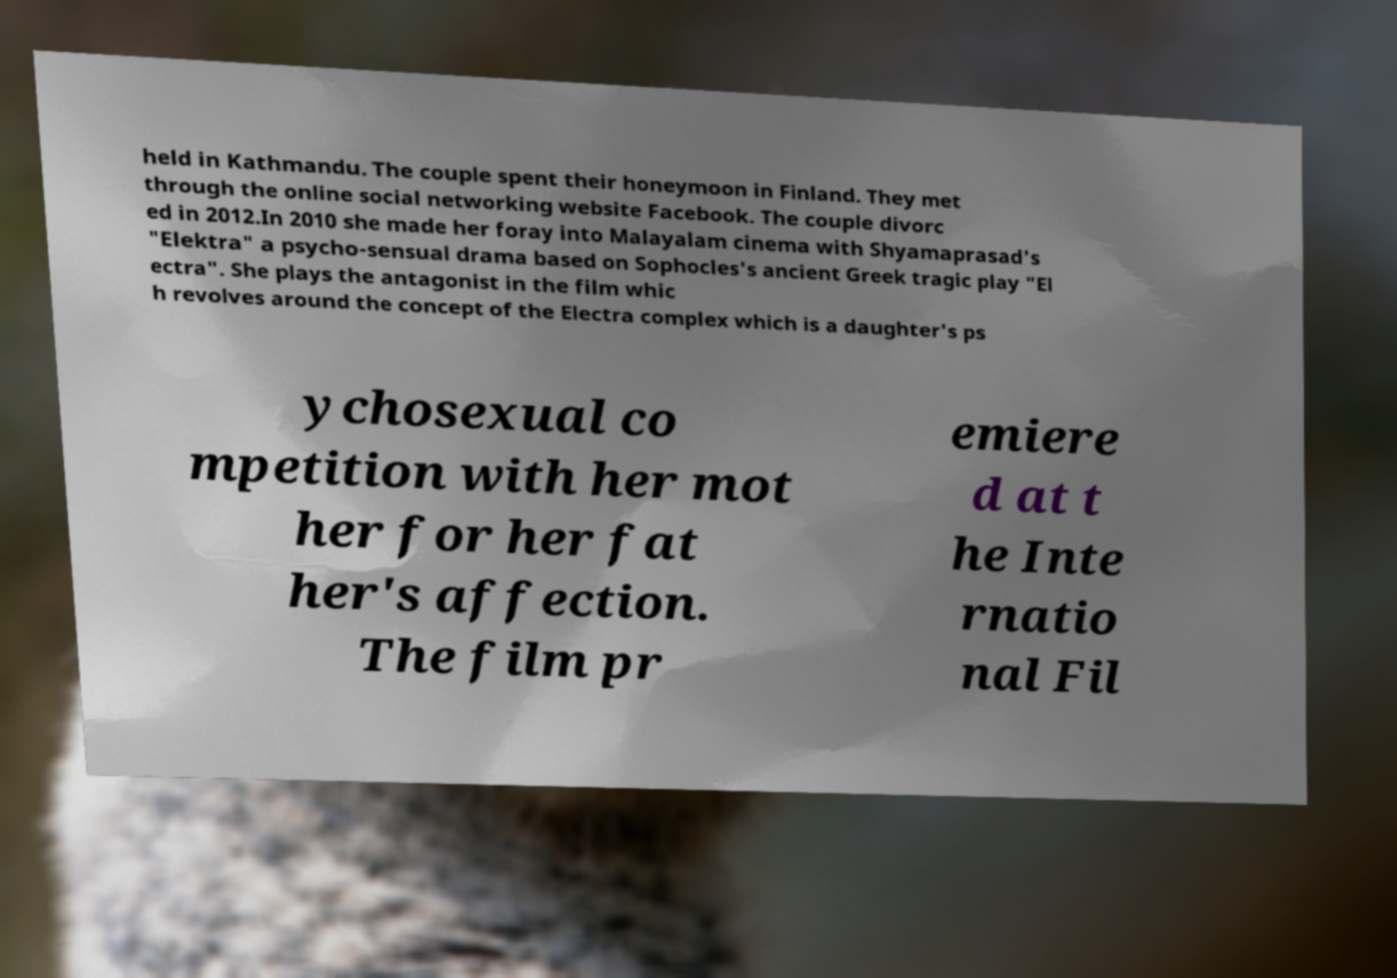Please identify and transcribe the text found in this image. held in Kathmandu. The couple spent their honeymoon in Finland. They met through the online social networking website Facebook. The couple divorc ed in 2012.In 2010 she made her foray into Malayalam cinema with Shyamaprasad's "Elektra" a psycho-sensual drama based on Sophocles's ancient Greek tragic play "El ectra". She plays the antagonist in the film whic h revolves around the concept of the Electra complex which is a daughter's ps ychosexual co mpetition with her mot her for her fat her's affection. The film pr emiere d at t he Inte rnatio nal Fil 